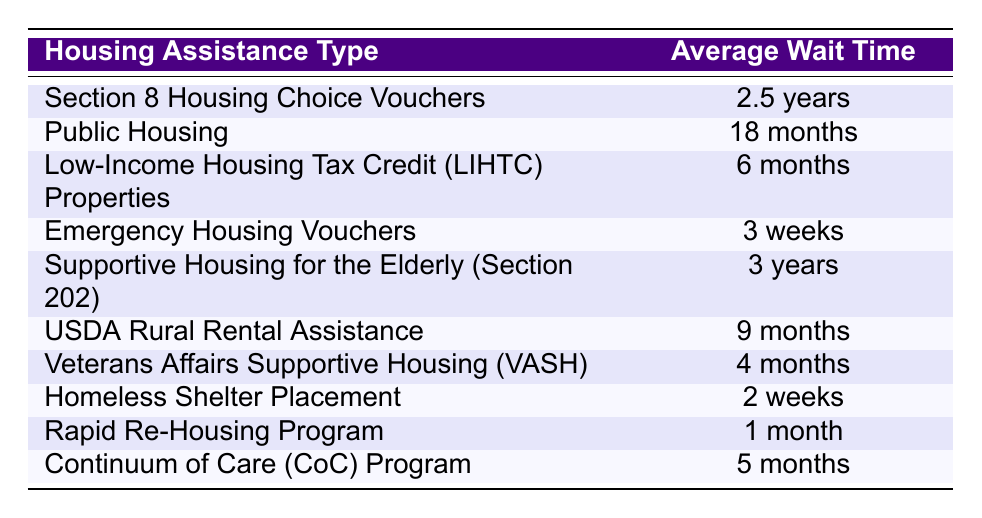What is the average wait time for Emergency Housing Vouchers? The table shows that the average wait time for Emergency Housing Vouchers is listed as 3 weeks. This value can be directly found in the second column corresponding to the row for Emergency Housing Vouchers.
Answer: 3 weeks Which housing assistance type has the longest wait time? By inspecting the table, Section 8 Housing Choice Vouchers has the longest average wait time of 2.5 years. This is the value in the row for Section 8 Housing Choice Vouchers in the second column, and it is longer than all other wait times listed.
Answer: Section 8 Housing Choice Vouchers Is the average wait time for Public Housing more than a year? The average wait time for Public Housing is 18 months, which is equivalent to 1.5 years. Since 1.5 years is greater than 1 year, the statement is true. This comparison requires converting 18 months to years to clearly determine it exceeds 1 year.
Answer: Yes How many types of housing assistance have a wait time of less than 6 months? The table shows Low-Income Housing Tax Credit Properties (6 months), Emergency Housing Vouchers (3 weeks), Veterans Affairs Supportive Housing (4 months), and Homeless Shelter Placement (2 weeks) as the only types under 6 months. We analyze each entry in the average wait time column: 3 weeks and 2 weeks are indeed less than 6 months, indicating 4 types in total.
Answer: 4 What is the difference in average wait time between Supportive Housing for the Elderly (Section 202) and Veterans Affairs Supportive Housing (VASH)? The average wait time for Supportive Housing for the Elderly (Section 202) is 3 years, while for Veterans Affairs Supportive Housing (VASH) it is 4 months. To find the difference, we convert 3 years into months (3 years = 36 months) and subtract the wait time for VASH: 36 months - 4 months = 32 months. Thus, the difference in wait time is 32 months.
Answer: 32 months Are the average wait times for Rapid Re-Housing Program and Continuum of Care (CoC) Program the same? The average wait time for the Rapid Re-Housing Program is listed as 1 month, while for the Continuum of Care (CoC) Program it is 5 months. Comparing these two values shows they are not the same because 1 month is less than 5 months.
Answer: No What is the average wait time for low-income housing assistance in months? The relevant assistance options with wait times are Section 8 (30 months), Public Housing (18 months), LIHTC Properties (6 months), USDA Rural Assistance (9 months), VASH (4 months), CoC (5 months), and Rapid Re-Housing (1 month). To find the average, we would sum their wait times: 30 + 18 + 6 + 9 + 4 + 5 + 1 = 73 months and divide by 7 (the number of types): 73/7 = approximately 10.43 months.
Answer: 10.43 months What housing assistance type has the shortest average wait time? By looking at the table, the shortest average wait time is associated with Homeless Shelter Placement, which is 2 weeks. This can be directly identified by scanning through the wait times, allowing us to determine it is the minimal value.
Answer: Homeless Shelter Placement 